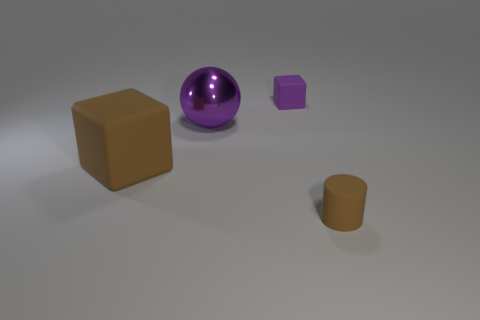Add 2 tiny blue things. How many objects exist? 6 Subtract all balls. How many objects are left? 3 Add 1 big cubes. How many big cubes are left? 2 Add 2 purple rubber cubes. How many purple rubber cubes exist? 3 Subtract 0 gray cubes. How many objects are left? 4 Subtract all red matte spheres. Subtract all brown matte cubes. How many objects are left? 3 